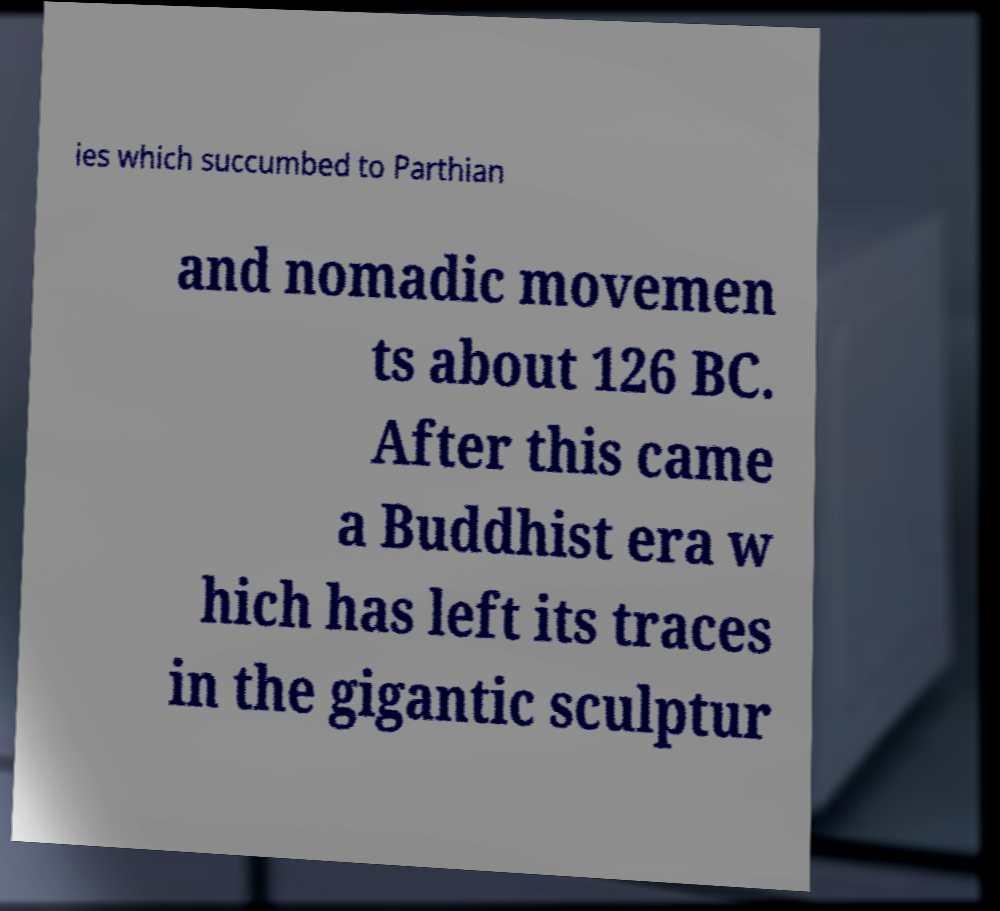For documentation purposes, I need the text within this image transcribed. Could you provide that? ies which succumbed to Parthian and nomadic movemen ts about 126 BC. After this came a Buddhist era w hich has left its traces in the gigantic sculptur 